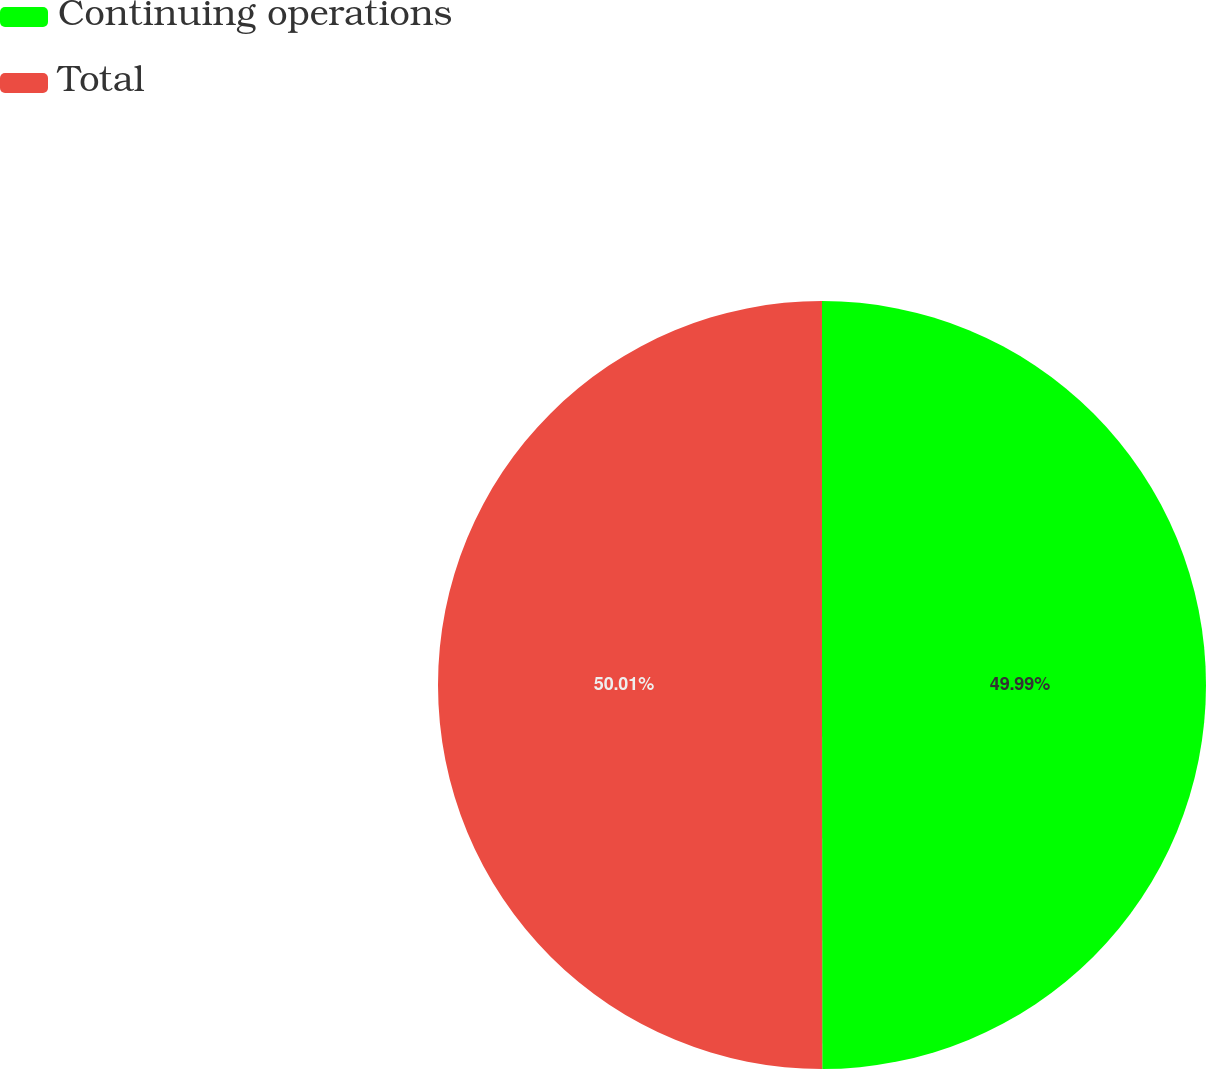Convert chart. <chart><loc_0><loc_0><loc_500><loc_500><pie_chart><fcel>Continuing operations<fcel>Total<nl><fcel>49.99%<fcel>50.01%<nl></chart> 